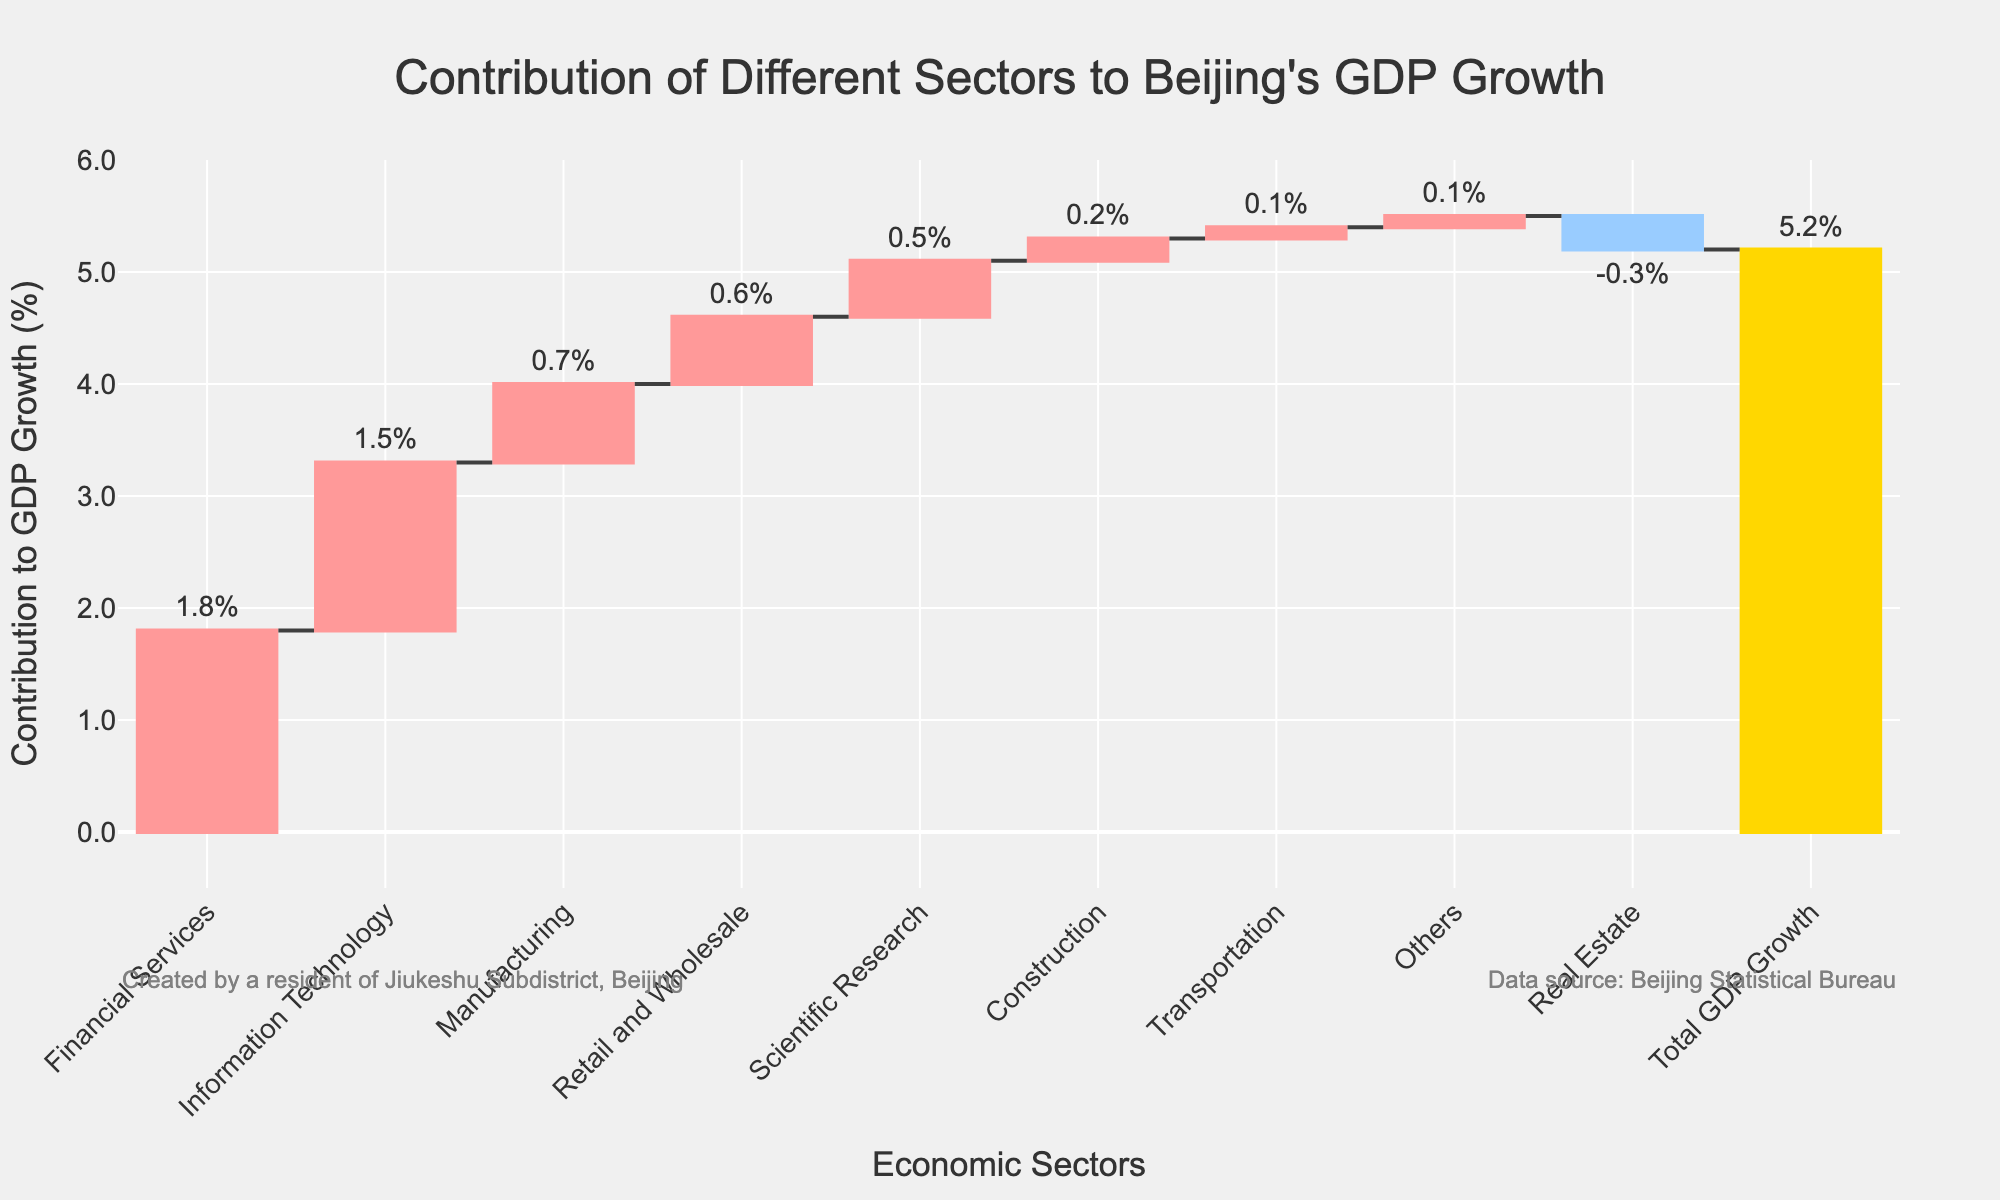What is the title of the figure? The title is located at the top and center of the chart. It is styled larger and bold to make it stand out.
Answer: Contribution of Different Sectors to Beijing's GDP Growth How much did the financial services sector contribute to Beijing's GDP growth? Look for the financial services bar in the chart, check the label on top of the bar which indicates the contribution.
Answer: 1.8% What sector had a negative contribution, and what was its value? Identify any downward (decreasing) bars in a waterfall chart, signifying negative contributions. The sector here is Real Estate, and its value is indicated at the top of the corresponding bar.
Answer: Real Estate, -0.3% Which sector made the smallest positive contribution to GDP growth? Examine the bars representing positive contributions, find the one with the smallest height and check its label.
Answer: Transportation, 0.1% How many sectors contributed positively to the GDP growth? Count the number of bars that go upwards in the waterfall chart, indicating positive contributions.
Answer: 7 sectors Which sector had the highest contribution to GDP growth? Look for the tallest bar among the positive contributions and identify its label.
Answer: Financial Services What is the sum of contributions from the information technology and scientific research sectors? Add the contributions from the Information Technology sector (1.5%) and the Scientific Research sector (0.5%).
Answer: 2.0% What is the net contribution to GDP growth from the real estate and construction sectors combined? Add the contributions from Real Estate (-0.3%) and Construction (0.2%). The net contribution is the sum of these values.
Answer: -0.1% Was the total GDP growth positive, negative, or zero? Look for the Total GDP Growth bar at the end of the chart and check if it points upwards, downwards, or is flat.
Answer: Positive How does the contribution of the retail and wholesale sector compare to that of the manufacturing sector? Compare the height (value) of the bars for Retail and Wholesale (0.6%) and Manufacturing (0.7%) sectors.
Answer: Manufacturing contributed more 